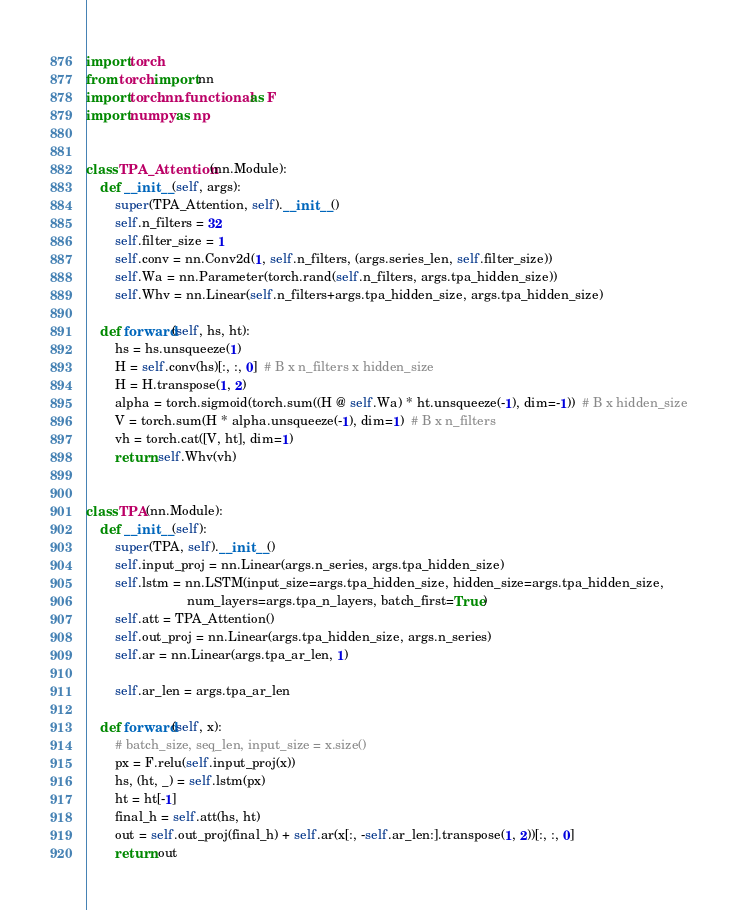Convert code to text. <code><loc_0><loc_0><loc_500><loc_500><_Python_>import torch
from torch import nn
import torch.nn.functional as F
import numpy as np


class TPA_Attention(nn.Module):
    def __init__(self, args):
        super(TPA_Attention, self).__init__()
        self.n_filters = 32
        self.filter_size = 1
        self.conv = nn.Conv2d(1, self.n_filters, (args.series_len, self.filter_size))
        self.Wa = nn.Parameter(torch.rand(self.n_filters, args.tpa_hidden_size))
        self.Whv = nn.Linear(self.n_filters+args.tpa_hidden_size, args.tpa_hidden_size)

    def forward(self, hs, ht):
        hs = hs.unsqueeze(1)
        H = self.conv(hs)[:, :, 0]  # B x n_filters x hidden_size
        H = H.transpose(1, 2)
        alpha = torch.sigmoid(torch.sum((H @ self.Wa) * ht.unsqueeze(-1), dim=-1))  # B x hidden_size
        V = torch.sum(H * alpha.unsqueeze(-1), dim=1)  # B x n_filters
        vh = torch.cat([V, ht], dim=1)
        return self.Whv(vh)


class TPA(nn.Module):
    def __init__(self):
        super(TPA, self).__init__()
        self.input_proj = nn.Linear(args.n_series, args.tpa_hidden_size)
        self.lstm = nn.LSTM(input_size=args.tpa_hidden_size, hidden_size=args.tpa_hidden_size,
                            num_layers=args.tpa_n_layers, batch_first=True)
        self.att = TPA_Attention()
        self.out_proj = nn.Linear(args.tpa_hidden_size, args.n_series)
        self.ar = nn.Linear(args.tpa_ar_len, 1)

        self.ar_len = args.tpa_ar_len

    def forward(self, x):
        # batch_size, seq_len, input_size = x.size()
        px = F.relu(self.input_proj(x))
        hs, (ht, _) = self.lstm(px)
        ht = ht[-1]
        final_h = self.att(hs, ht)
        out = self.out_proj(final_h) + self.ar(x[:, -self.ar_len:].transpose(1, 2))[:, :, 0]
        return out
</code> 